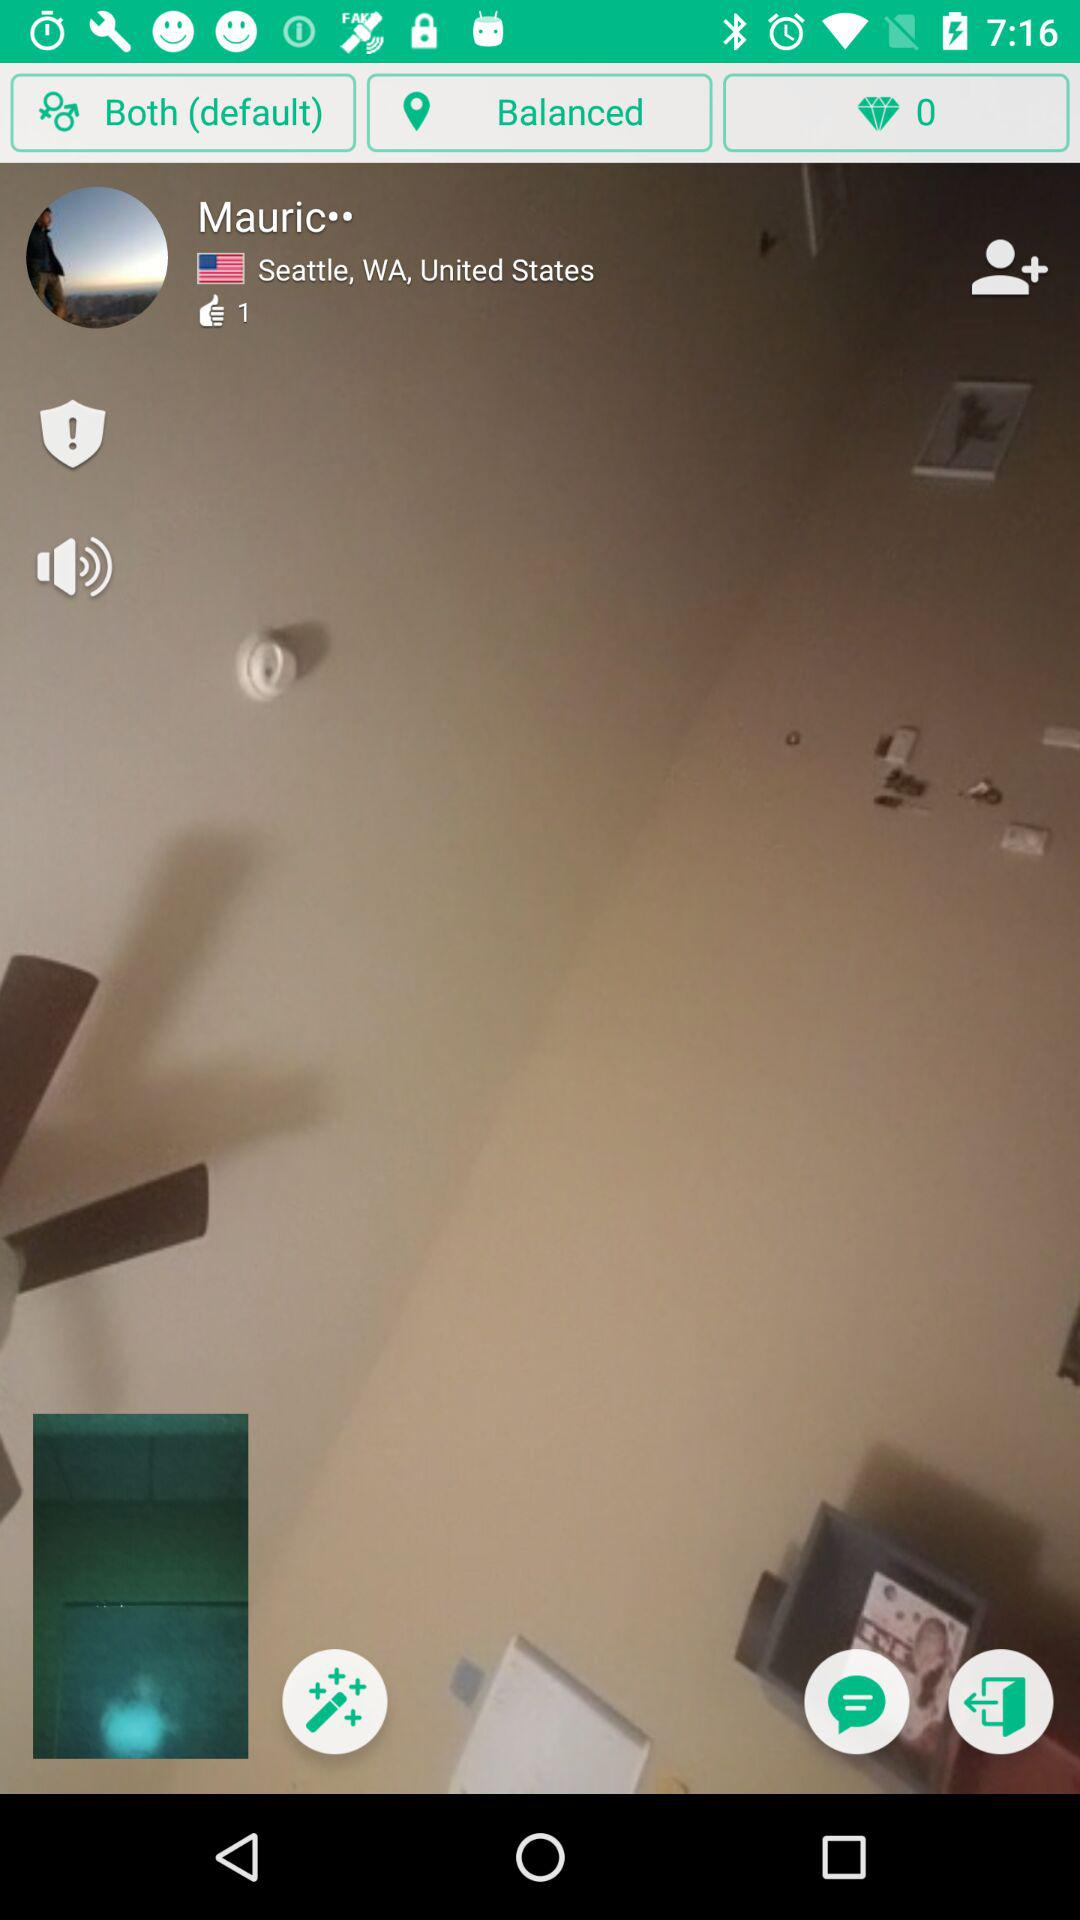How many likes are on the profile? There is 1 like on the profile. 